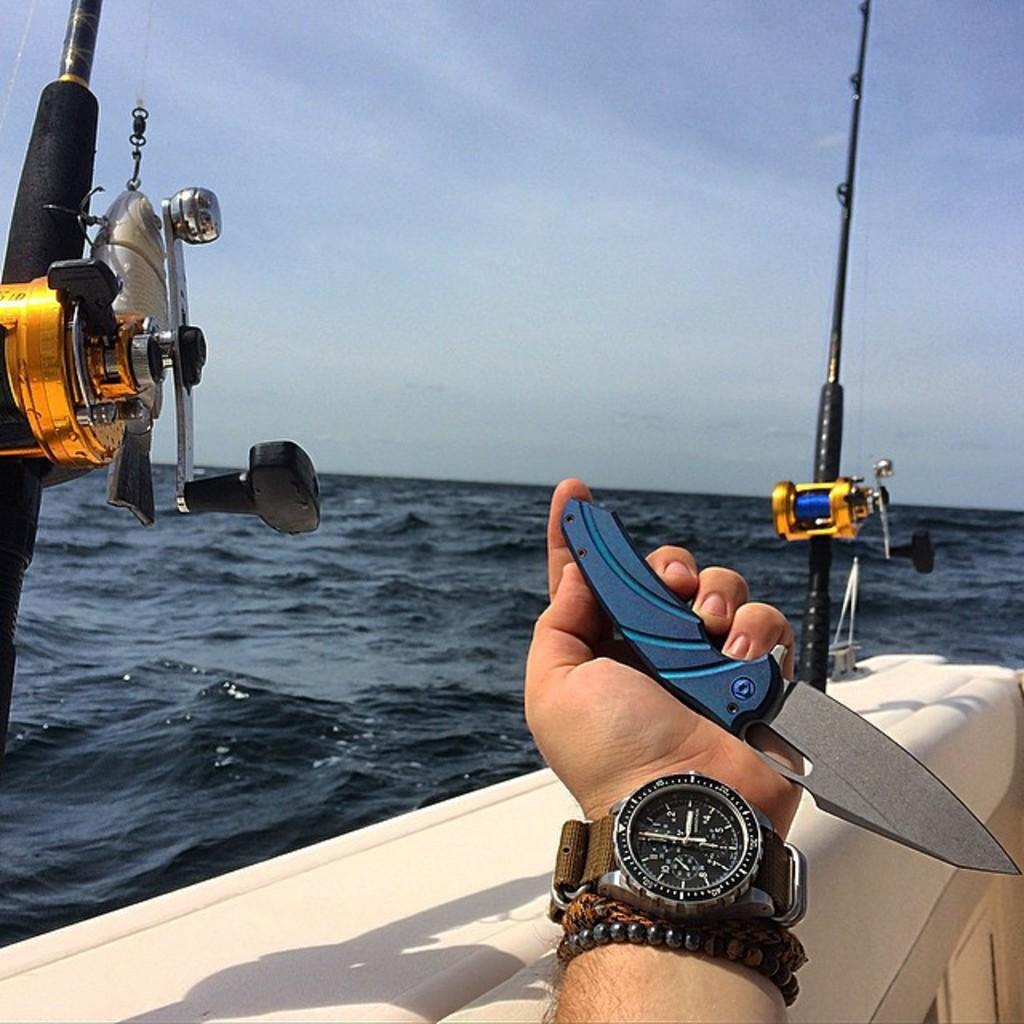<image>
Give a short and clear explanation of the subsequent image. A man holding a knife and wearing a watch sitting on a fishing boat. 